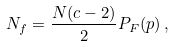<formula> <loc_0><loc_0><loc_500><loc_500>N _ { f } = \frac { N ( c - 2 ) } { 2 } P _ { F } ( p ) \, ,</formula> 